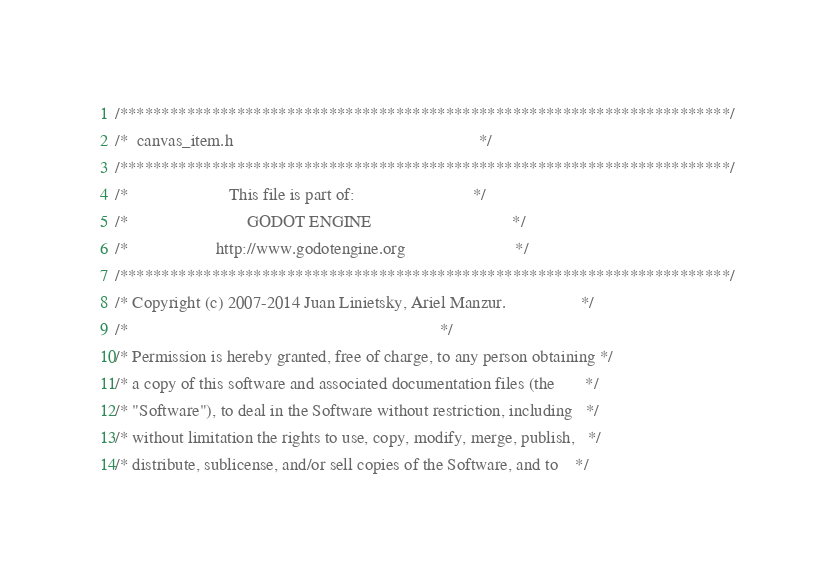Convert code to text. <code><loc_0><loc_0><loc_500><loc_500><_C_>/*************************************************************************/
/*  canvas_item.h                                                        */
/*************************************************************************/
/*                       This file is part of:                           */
/*                           GODOT ENGINE                                */
/*                    http://www.godotengine.org                         */
/*************************************************************************/
/* Copyright (c) 2007-2014 Juan Linietsky, Ariel Manzur.                 */
/*                                                                       */
/* Permission is hereby granted, free of charge, to any person obtaining */
/* a copy of this software and associated documentation files (the       */
/* "Software"), to deal in the Software without restriction, including   */
/* without limitation the rights to use, copy, modify, merge, publish,   */
/* distribute, sublicense, and/or sell copies of the Software, and to    */</code> 